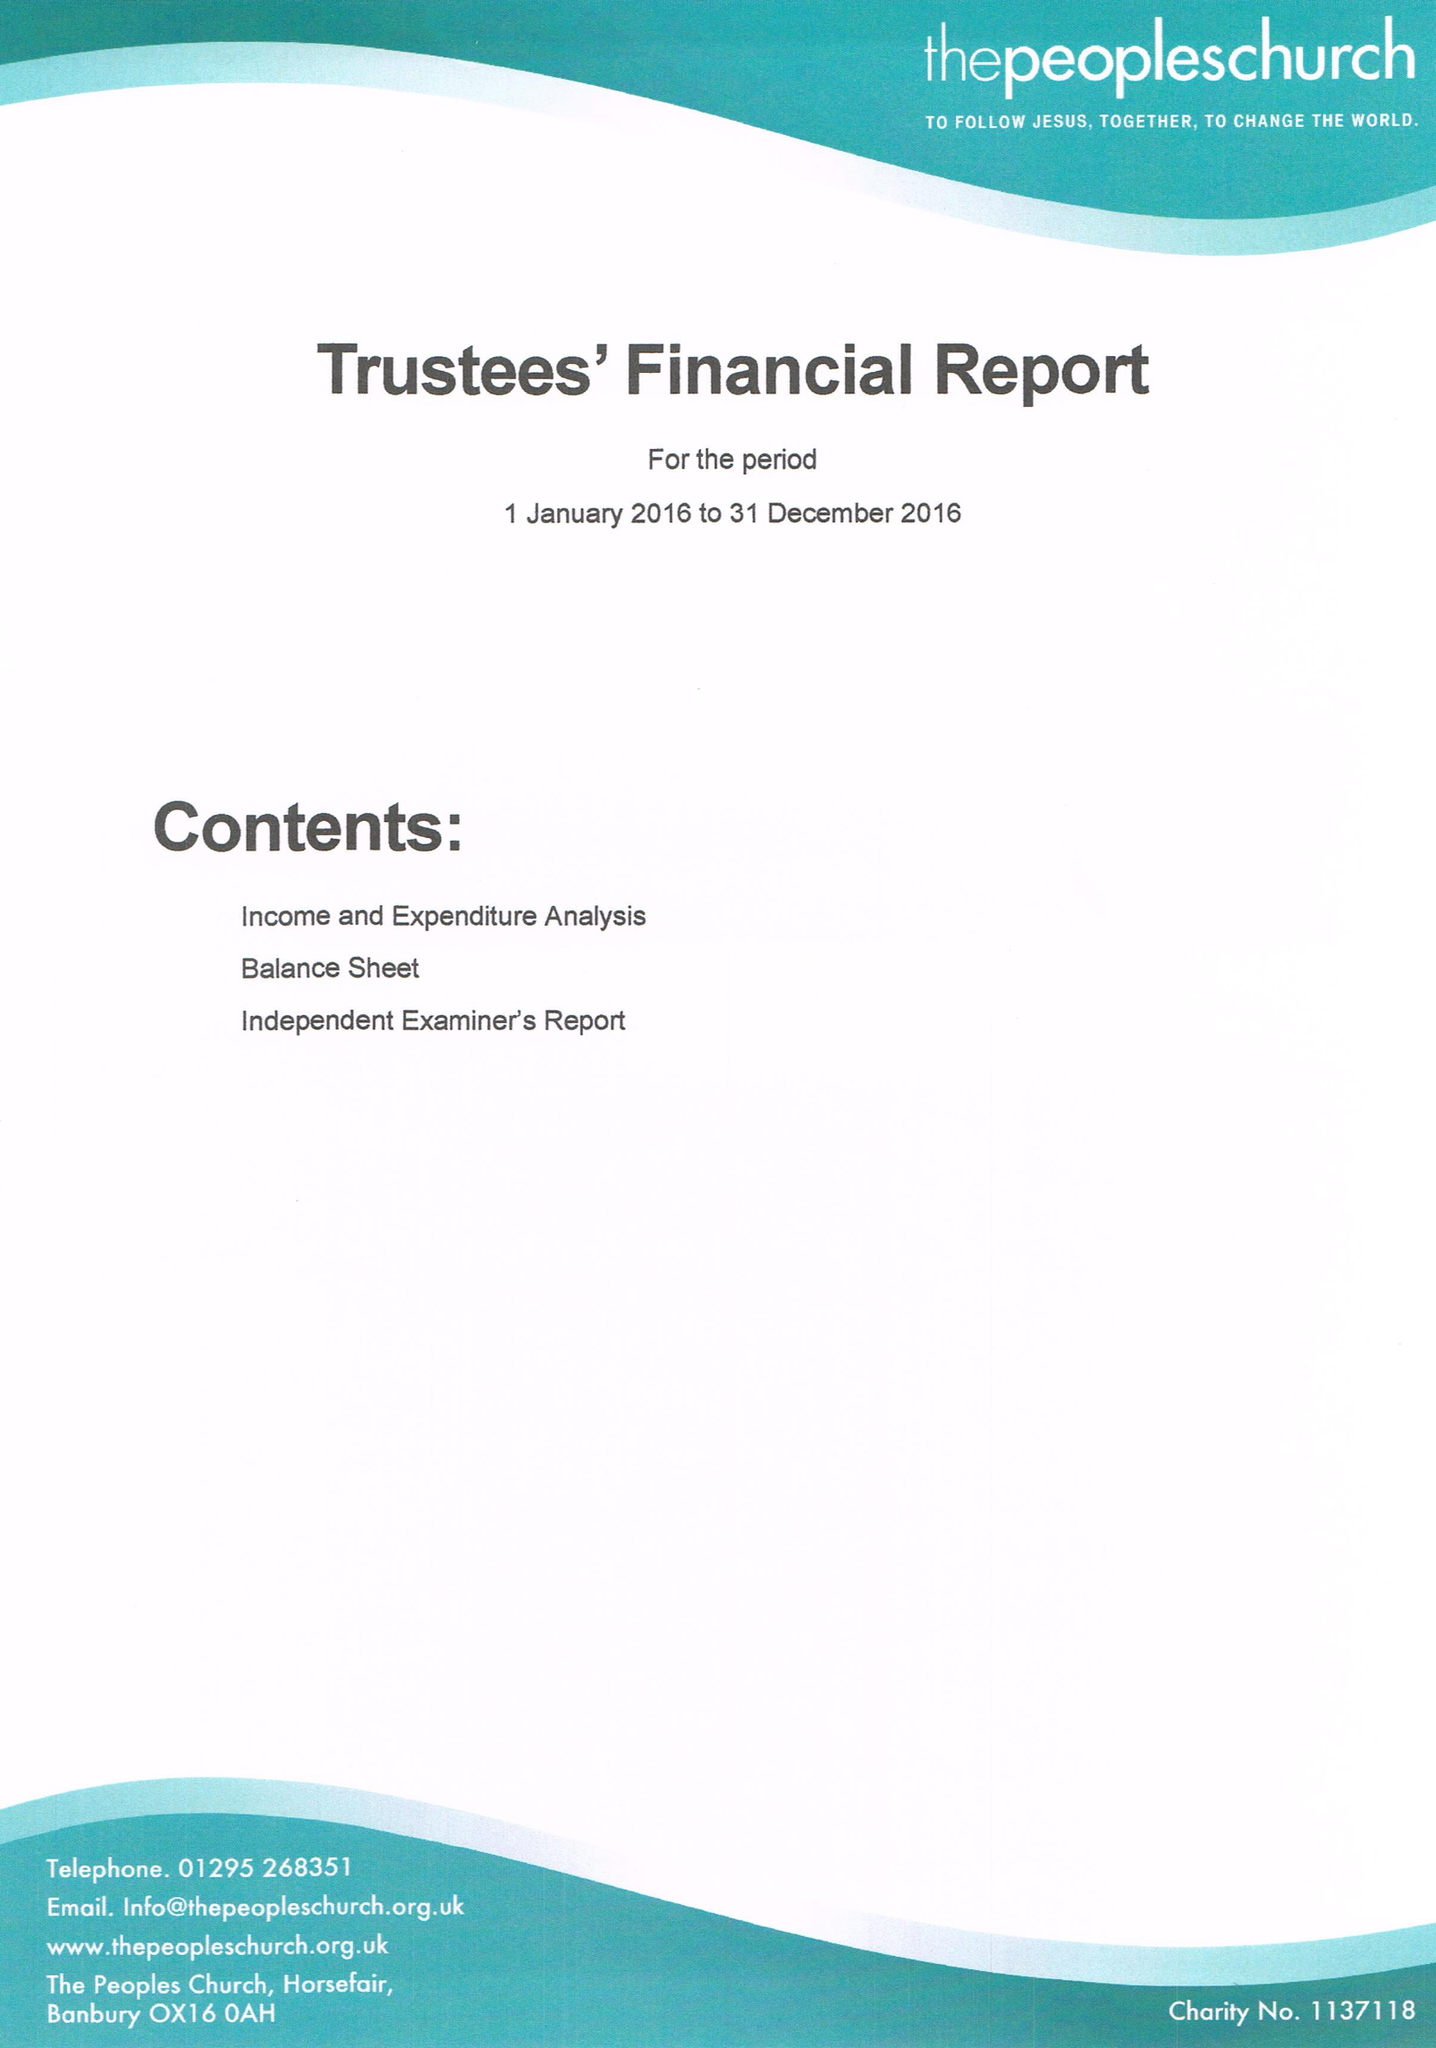What is the value for the address__street_line?
Answer the question using a single word or phrase. HORSE FAIR 